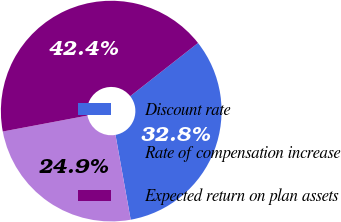<chart> <loc_0><loc_0><loc_500><loc_500><pie_chart><fcel>Discount rate<fcel>Rate of compensation increase<fcel>Expected return on plan assets<nl><fcel>32.77%<fcel>24.86%<fcel>42.37%<nl></chart> 